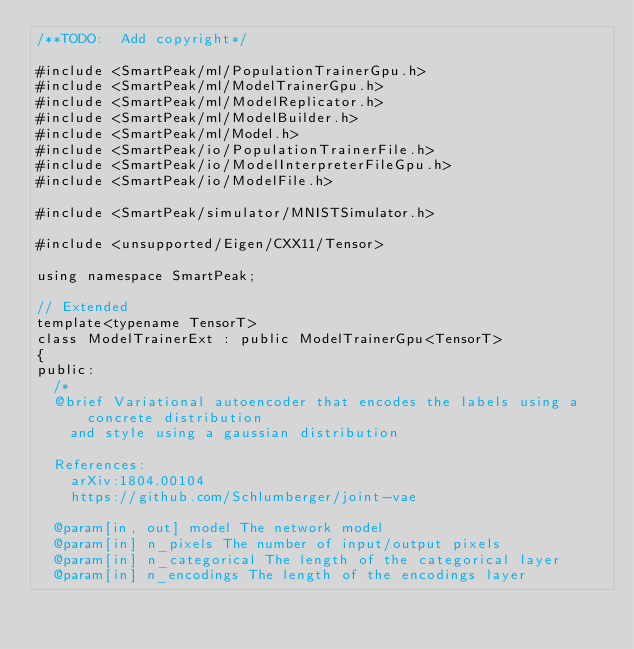Convert code to text. <code><loc_0><loc_0><loc_500><loc_500><_Cuda_>/**TODO:  Add copyright*/

#include <SmartPeak/ml/PopulationTrainerGpu.h>
#include <SmartPeak/ml/ModelTrainerGpu.h>
#include <SmartPeak/ml/ModelReplicator.h>
#include <SmartPeak/ml/ModelBuilder.h>
#include <SmartPeak/ml/Model.h>
#include <SmartPeak/io/PopulationTrainerFile.h>
#include <SmartPeak/io/ModelInterpreterFileGpu.h>
#include <SmartPeak/io/ModelFile.h>

#include <SmartPeak/simulator/MNISTSimulator.h>

#include <unsupported/Eigen/CXX11/Tensor>

using namespace SmartPeak;

// Extended 
template<typename TensorT>
class ModelTrainerExt : public ModelTrainerGpu<TensorT>
{
public:
  /*
  @brief Variational autoencoder that encodes the labels using a concrete distribution
    and style using a gaussian distribution

  References:
    arXiv:1804.00104
    https://github.com/Schlumberger/joint-vae

  @param[in, out] model The network model
  @param[in] n_pixels The number of input/output pixels
  @param[in] n_categorical The length of the categorical layer
  @param[in] n_encodings The length of the encodings layer</code> 